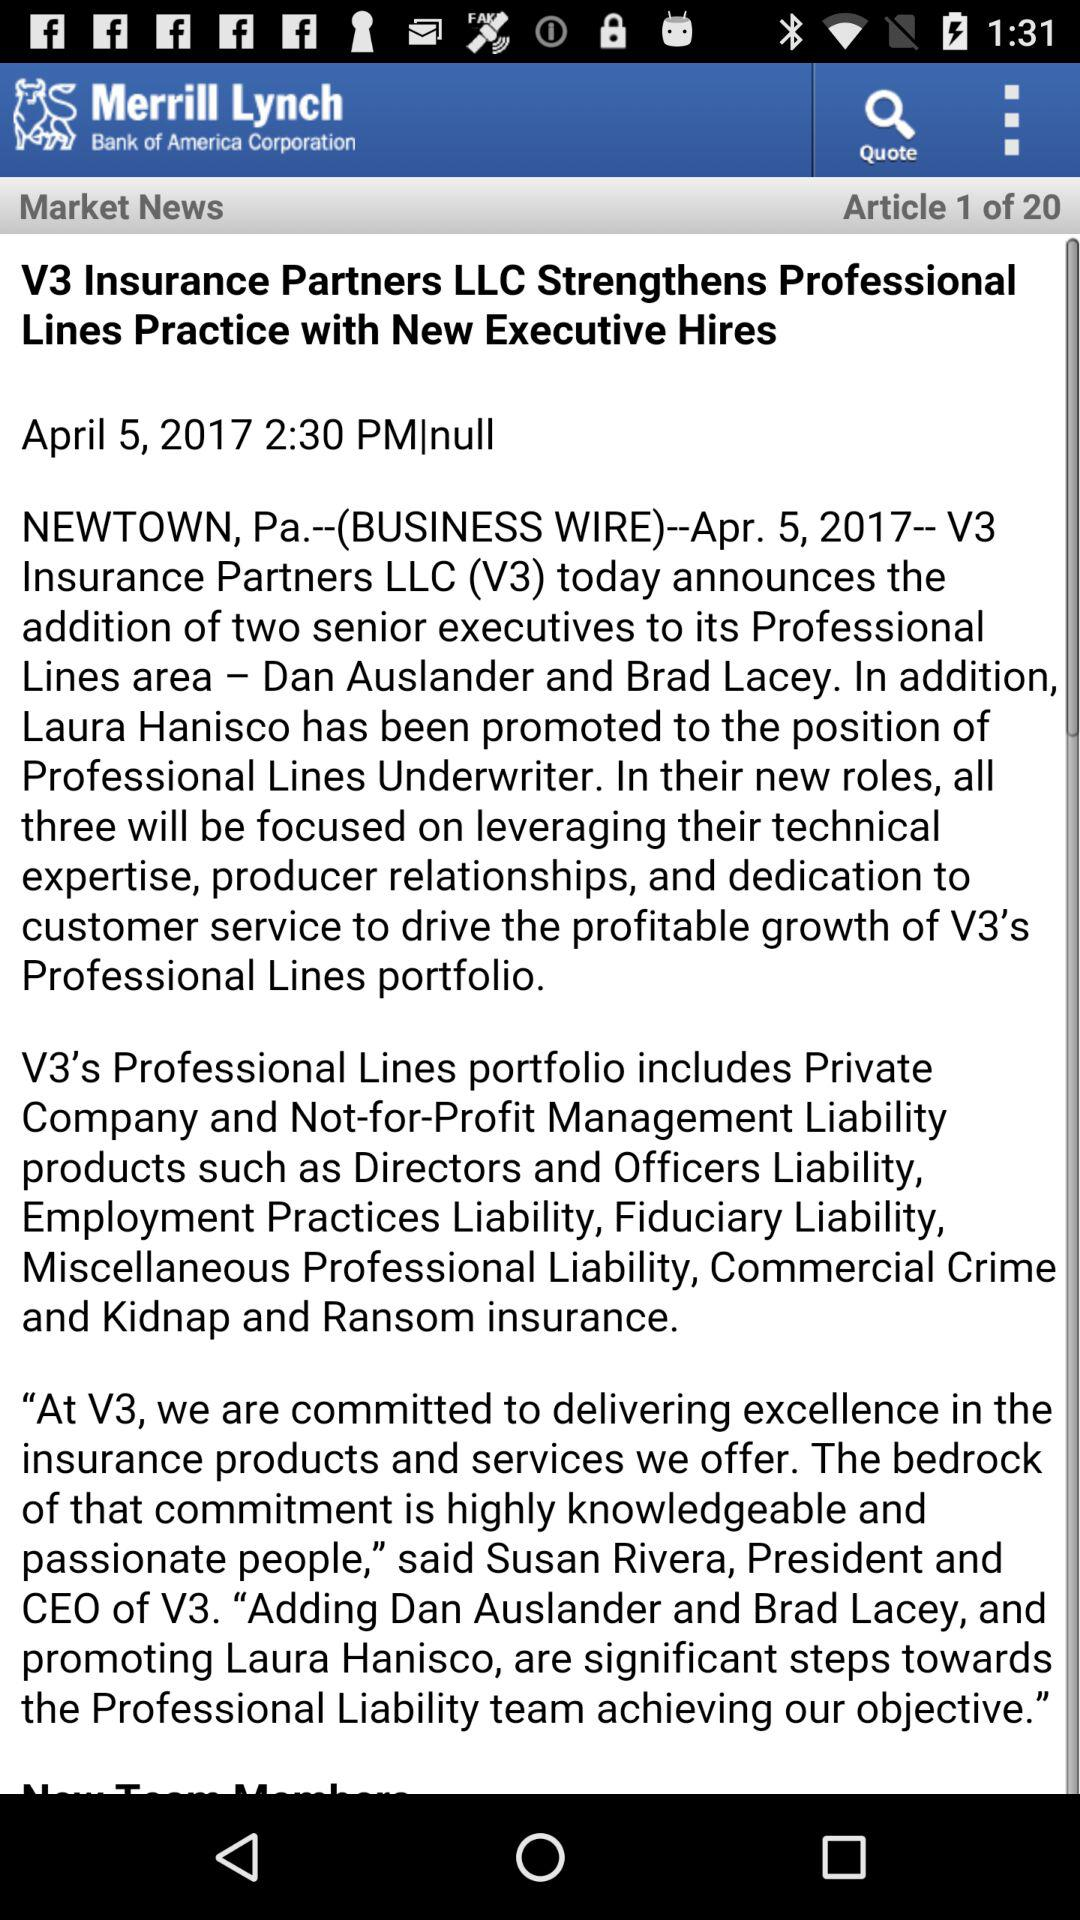What is the total number of articles displayed? The total number of articles is 20. 